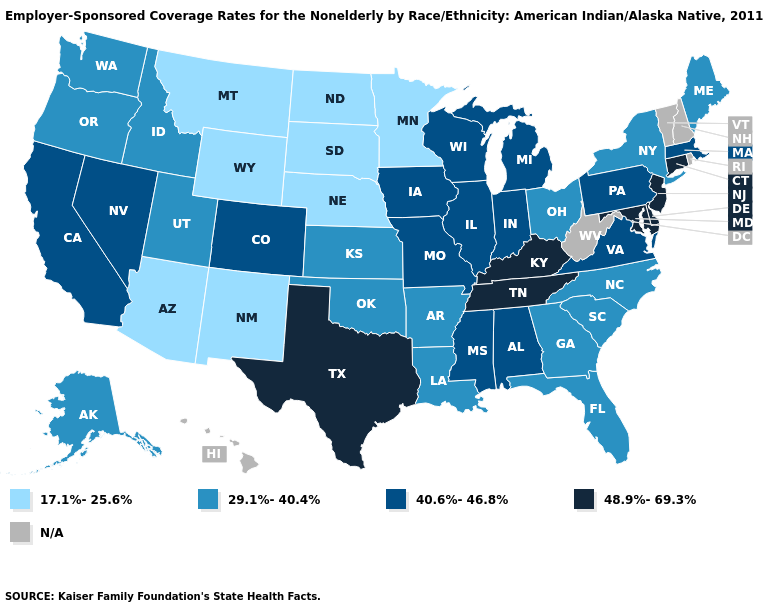Is the legend a continuous bar?
Answer briefly. No. What is the value of South Dakota?
Keep it brief. 17.1%-25.6%. What is the lowest value in the West?
Write a very short answer. 17.1%-25.6%. What is the value of Florida?
Be succinct. 29.1%-40.4%. Is the legend a continuous bar?
Concise answer only. No. Name the states that have a value in the range 40.6%-46.8%?
Short answer required. Alabama, California, Colorado, Illinois, Indiana, Iowa, Massachusetts, Michigan, Mississippi, Missouri, Nevada, Pennsylvania, Virginia, Wisconsin. Does the map have missing data?
Short answer required. Yes. What is the highest value in the MidWest ?
Keep it brief. 40.6%-46.8%. Which states have the lowest value in the USA?
Write a very short answer. Arizona, Minnesota, Montana, Nebraska, New Mexico, North Dakota, South Dakota, Wyoming. Name the states that have a value in the range 40.6%-46.8%?
Answer briefly. Alabama, California, Colorado, Illinois, Indiana, Iowa, Massachusetts, Michigan, Mississippi, Missouri, Nevada, Pennsylvania, Virginia, Wisconsin. What is the value of Kansas?
Give a very brief answer. 29.1%-40.4%. Which states have the lowest value in the USA?
Be succinct. Arizona, Minnesota, Montana, Nebraska, New Mexico, North Dakota, South Dakota, Wyoming. Name the states that have a value in the range N/A?
Give a very brief answer. Hawaii, New Hampshire, Rhode Island, Vermont, West Virginia. Name the states that have a value in the range 29.1%-40.4%?
Quick response, please. Alaska, Arkansas, Florida, Georgia, Idaho, Kansas, Louisiana, Maine, New York, North Carolina, Ohio, Oklahoma, Oregon, South Carolina, Utah, Washington. Name the states that have a value in the range 17.1%-25.6%?
Answer briefly. Arizona, Minnesota, Montana, Nebraska, New Mexico, North Dakota, South Dakota, Wyoming. 